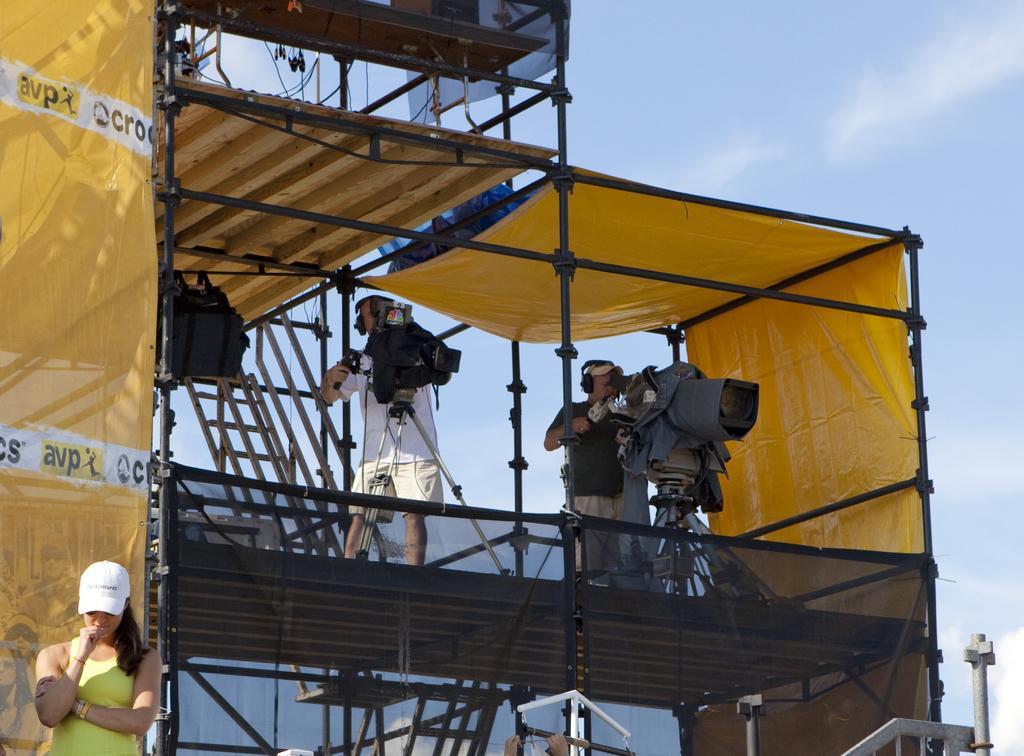Describe this image in one or two sentences. In this image we can see two people standing on the iron bars and there are cameras placed on the stands. We can see covers and sheds. In the background there are stairs and sky. On the left there is a lady. 